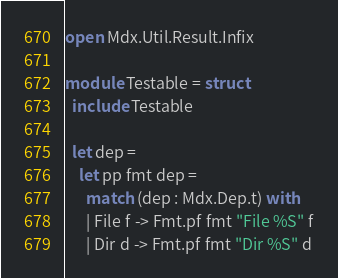Convert code to text. <code><loc_0><loc_0><loc_500><loc_500><_OCaml_>open Mdx.Util.Result.Infix

module Testable = struct
  include Testable

  let dep =
    let pp fmt dep =
      match (dep : Mdx.Dep.t) with
      | File f -> Fmt.pf fmt "File %S" f
      | Dir d -> Fmt.pf fmt "Dir %S" d</code> 